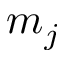<formula> <loc_0><loc_0><loc_500><loc_500>m _ { j }</formula> 